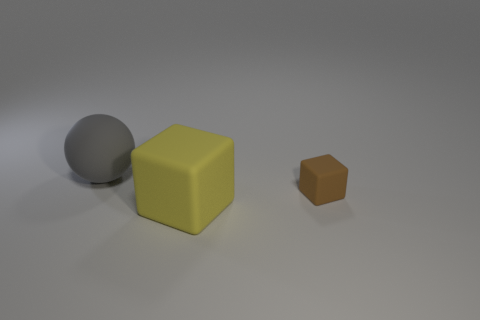The big matte sphere is what color?
Provide a succinct answer. Gray. How many tiny objects are either metal objects or gray rubber things?
Your answer should be compact. 0. Does the matte thing that is in front of the small thing have the same size as the thing that is behind the small thing?
Your response must be concise. Yes. What is the size of the other object that is the same shape as the brown object?
Your answer should be compact. Large. Are there more large yellow rubber cubes that are on the left side of the yellow matte thing than tiny things that are right of the large gray rubber thing?
Ensure brevity in your answer.  No. There is a object that is both behind the yellow object and left of the brown cube; what is it made of?
Make the answer very short. Rubber. There is a big thing that is the same shape as the small brown object; what color is it?
Give a very brief answer. Yellow. How big is the gray matte thing?
Keep it short and to the point. Large. What is the color of the thing in front of the object to the right of the large yellow block?
Give a very brief answer. Yellow. What number of things are in front of the gray matte ball and on the left side of the small brown matte block?
Offer a very short reply. 1. 